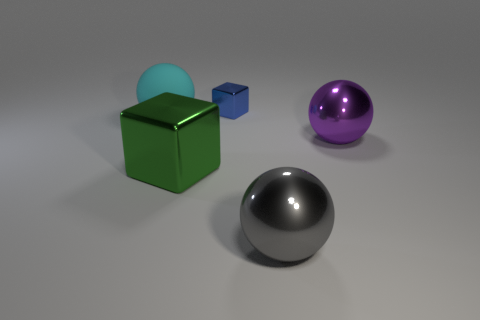Add 4 purple metallic objects. How many objects exist? 9 Subtract all spheres. How many objects are left? 2 Add 3 blue objects. How many blue objects exist? 4 Subtract 0 brown spheres. How many objects are left? 5 Subtract all red metallic spheres. Subtract all gray balls. How many objects are left? 4 Add 4 blocks. How many blocks are left? 6 